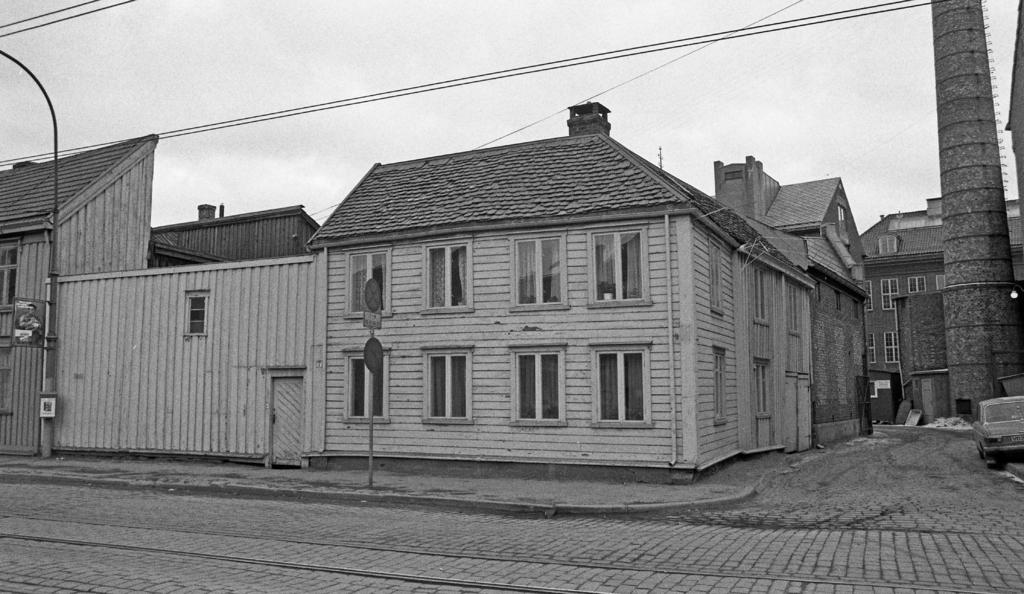What type of picture is in the image? The image contains an animated picture. What can be seen in the animated picture? There are houses and poles in the animated picture. What type of drum can be seen in the image? There is no drum present in the image; it contains an animated picture with houses and poles. 